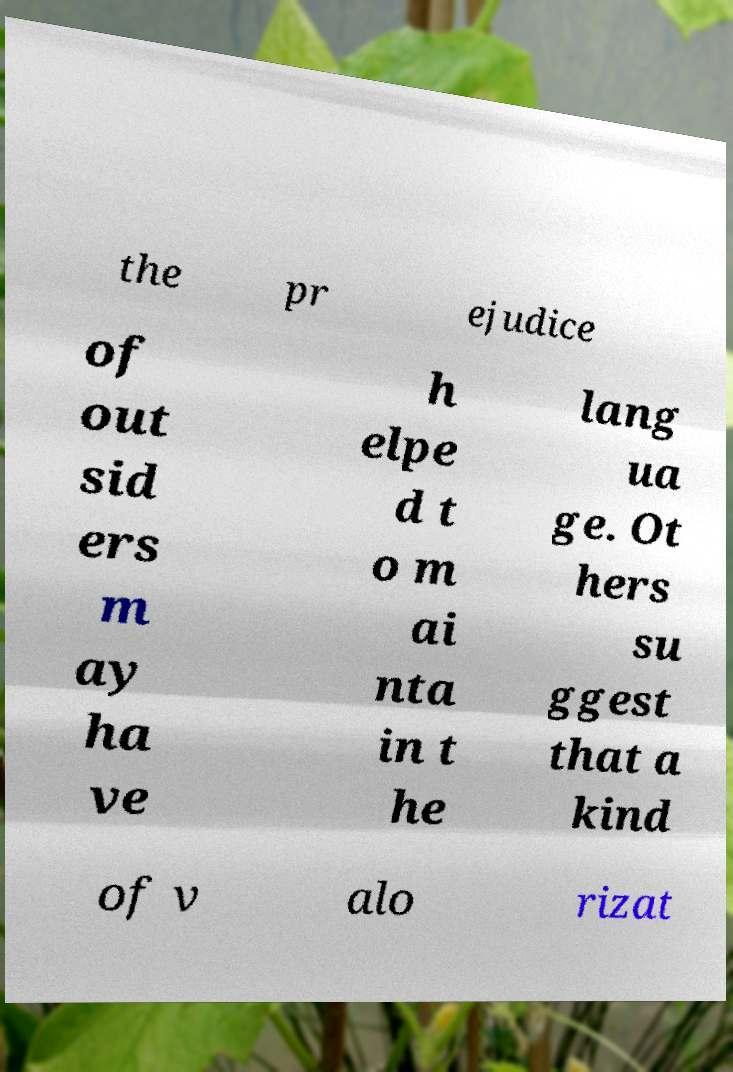There's text embedded in this image that I need extracted. Can you transcribe it verbatim? the pr ejudice of out sid ers m ay ha ve h elpe d t o m ai nta in t he lang ua ge. Ot hers su ggest that a kind of v alo rizat 